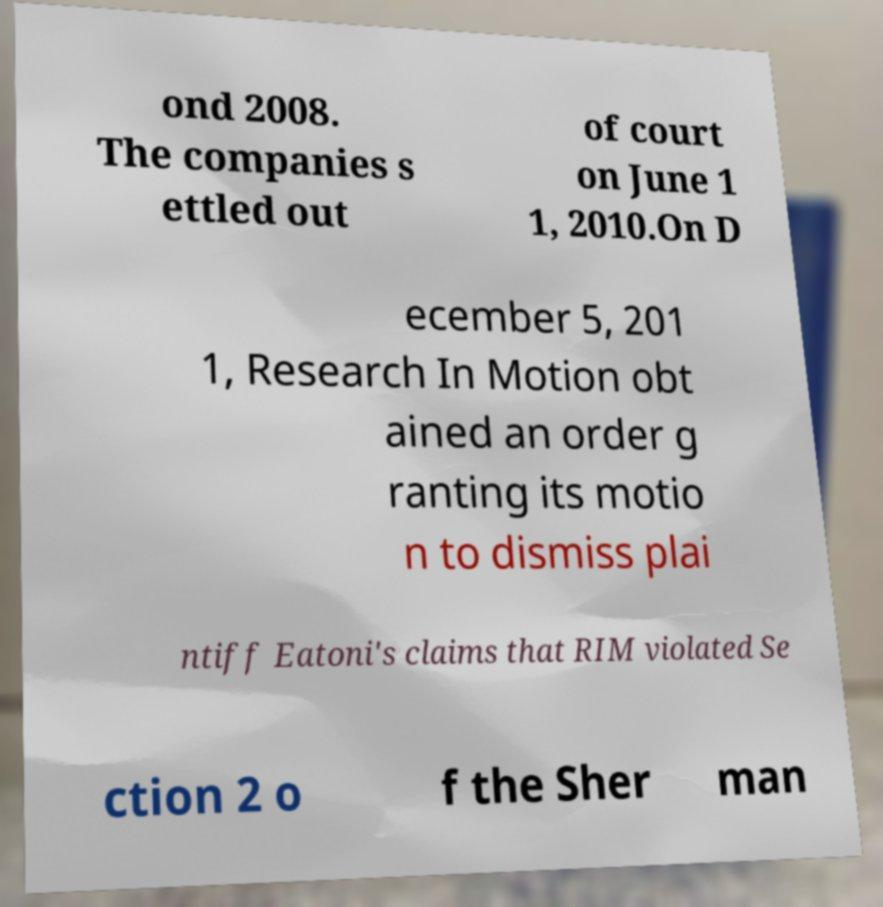Please identify and transcribe the text found in this image. ond 2008. The companies s ettled out of court on June 1 1, 2010.On D ecember 5, 201 1, Research In Motion obt ained an order g ranting its motio n to dismiss plai ntiff Eatoni's claims that RIM violated Se ction 2 o f the Sher man 